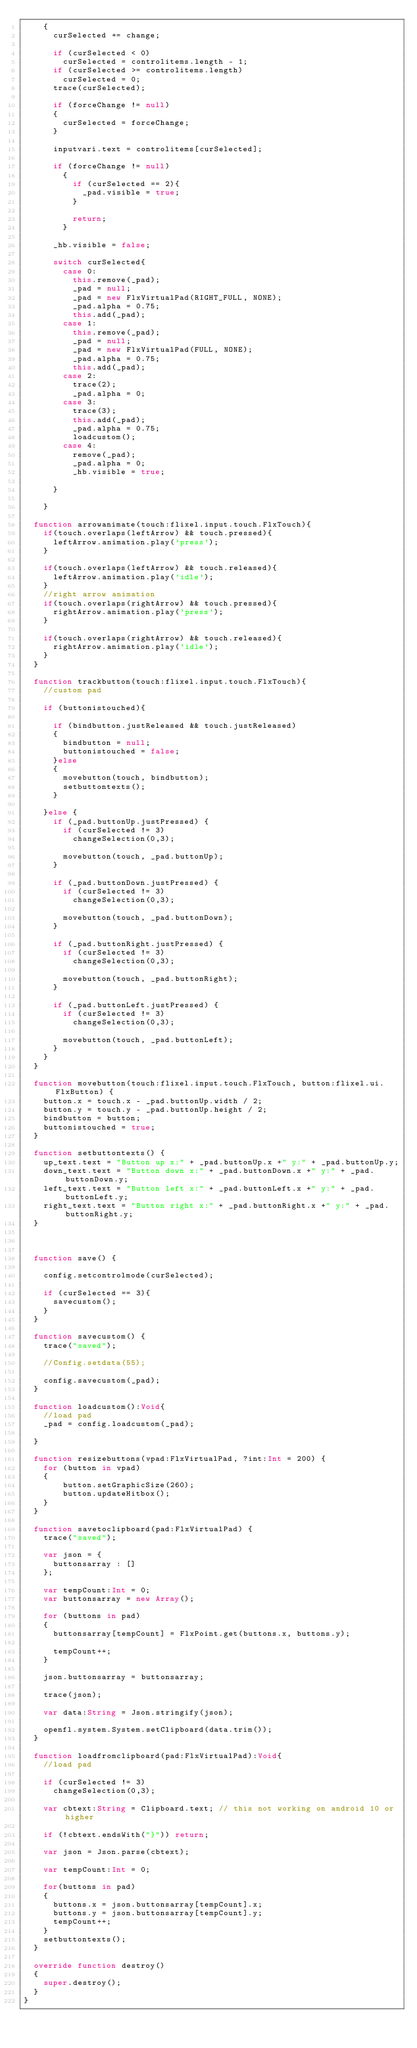<code> <loc_0><loc_0><loc_500><loc_500><_Haxe_>		{
			curSelected += change;
	
			if (curSelected < 0)
				curSelected = controlitems.length - 1;
			if (curSelected >= controlitems.length)
				curSelected = 0;
			trace(curSelected);
	
			if (forceChange != null)
			{
				curSelected = forceChange;
			}
	
			inputvari.text = controlitems[curSelected];

			if (forceChange != null)
				{
					if (curSelected == 2){
						_pad.visible = true;
					}
					
					return;
				}
			
			_hb.visible = false;
	
			switch curSelected{
				case 0:
					this.remove(_pad);
					_pad = null;
					_pad = new FlxVirtualPad(RIGHT_FULL, NONE);
					_pad.alpha = 0.75;
					this.add(_pad);
				case 1:
					this.remove(_pad);
					_pad = null;
					_pad = new FlxVirtualPad(FULL, NONE);
					_pad.alpha = 0.75;
					this.add(_pad);
				case 2:
					trace(2);
					_pad.alpha = 0;
				case 3:
					trace(3);
					this.add(_pad);
					_pad.alpha = 0.75;
					loadcustom();
				case 4:
					remove(_pad);
					_pad.alpha = 0;
					_hb.visible = true;

			}
	
		}

	function arrowanimate(touch:flixel.input.touch.FlxTouch){
		if(touch.overlaps(leftArrow) && touch.pressed){
			leftArrow.animation.play('press');
		}
		
		if(touch.overlaps(leftArrow) && touch.released){
			leftArrow.animation.play('idle');
		}
		//right arrow animation
		if(touch.overlaps(rightArrow) && touch.pressed){
			rightArrow.animation.play('press');
		}
		
		if(touch.overlaps(rightArrow) && touch.released){
			rightArrow.animation.play('idle');
		}
	}

	function trackbutton(touch:flixel.input.touch.FlxTouch){
		//custom pad

		if (buttonistouched){
			
			if (bindbutton.justReleased && touch.justReleased)
			{
				bindbutton = null;
				buttonistouched = false;
			}else 
			{
				movebutton(touch, bindbutton);
				setbuttontexts();
			}

		}else {
			if (_pad.buttonUp.justPressed) {
				if (curSelected != 3)
					changeSelection(0,3);

				movebutton(touch, _pad.buttonUp);
			}
			
			if (_pad.buttonDown.justPressed) {
				if (curSelected != 3)
					changeSelection(0,3);

				movebutton(touch, _pad.buttonDown);
			}

			if (_pad.buttonRight.justPressed) {
				if (curSelected != 3)
					changeSelection(0,3);

				movebutton(touch, _pad.buttonRight);
			}

			if (_pad.buttonLeft.justPressed) {
				if (curSelected != 3)
					changeSelection(0,3);

				movebutton(touch, _pad.buttonLeft);
			}
		}
	}

	function movebutton(touch:flixel.input.touch.FlxTouch, button:flixel.ui.FlxButton) {
		button.x = touch.x - _pad.buttonUp.width / 2;
		button.y = touch.y - _pad.buttonUp.height / 2;
		bindbutton = button;
		buttonistouched = true;
	}

	function setbuttontexts() {
		up_text.text = "Button up x:" + _pad.buttonUp.x +" y:" + _pad.buttonUp.y;
		down_text.text = "Button down x:" + _pad.buttonDown.x +" y:" + _pad.buttonDown.y;
		left_text.text = "Button left x:" + _pad.buttonLeft.x +" y:" + _pad.buttonLeft.y;
		right_text.text = "Button right x:" + _pad.buttonRight.x +" y:" + _pad.buttonRight.y;
	}



	function save() {

		config.setcontrolmode(curSelected);
		
		if (curSelected == 3){
			savecustom();
		}
	}

	function savecustom() {
		trace("saved");

		//Config.setdata(55);

		config.savecustom(_pad);
	}

	function loadcustom():Void{
		//load pad
		_pad = config.loadcustom(_pad);	
	
	}

	function resizebuttons(vpad:FlxVirtualPad, ?int:Int = 200) {
		for (button in vpad)
		{
				button.setGraphicSize(260);
				button.updateHitbox();
		}
	}

	function savetoclipboard(pad:FlxVirtualPad) {
		trace("saved");
		
		var json = {
			buttonsarray : []
		};

		var tempCount:Int = 0;
		var buttonsarray = new Array();
		
		for (buttons in pad)
		{
			buttonsarray[tempCount] = FlxPoint.get(buttons.x, buttons.y);

			tempCount++;
		}

		json.buttonsarray = buttonsarray;

		trace(json);

		var data:String = Json.stringify(json);

		openfl.system.System.setClipboard(data.trim());
	}

	function loadfromclipboard(pad:FlxVirtualPad):Void{
		//load pad

		if (curSelected != 3)
			changeSelection(0,3);

		var cbtext:String = Clipboard.text; // this not working on android 10 or higher

		if (!cbtext.endsWith("}")) return;

		var json = Json.parse(cbtext);

		var tempCount:Int = 0;

		for(buttons in pad)
		{
			buttons.x = json.buttonsarray[tempCount].x;
			buttons.y = json.buttonsarray[tempCount].y;
			tempCount++;
		}	
		setbuttontexts();
	}

	override function destroy()
	{
		super.destroy();
	}
}
</code> 